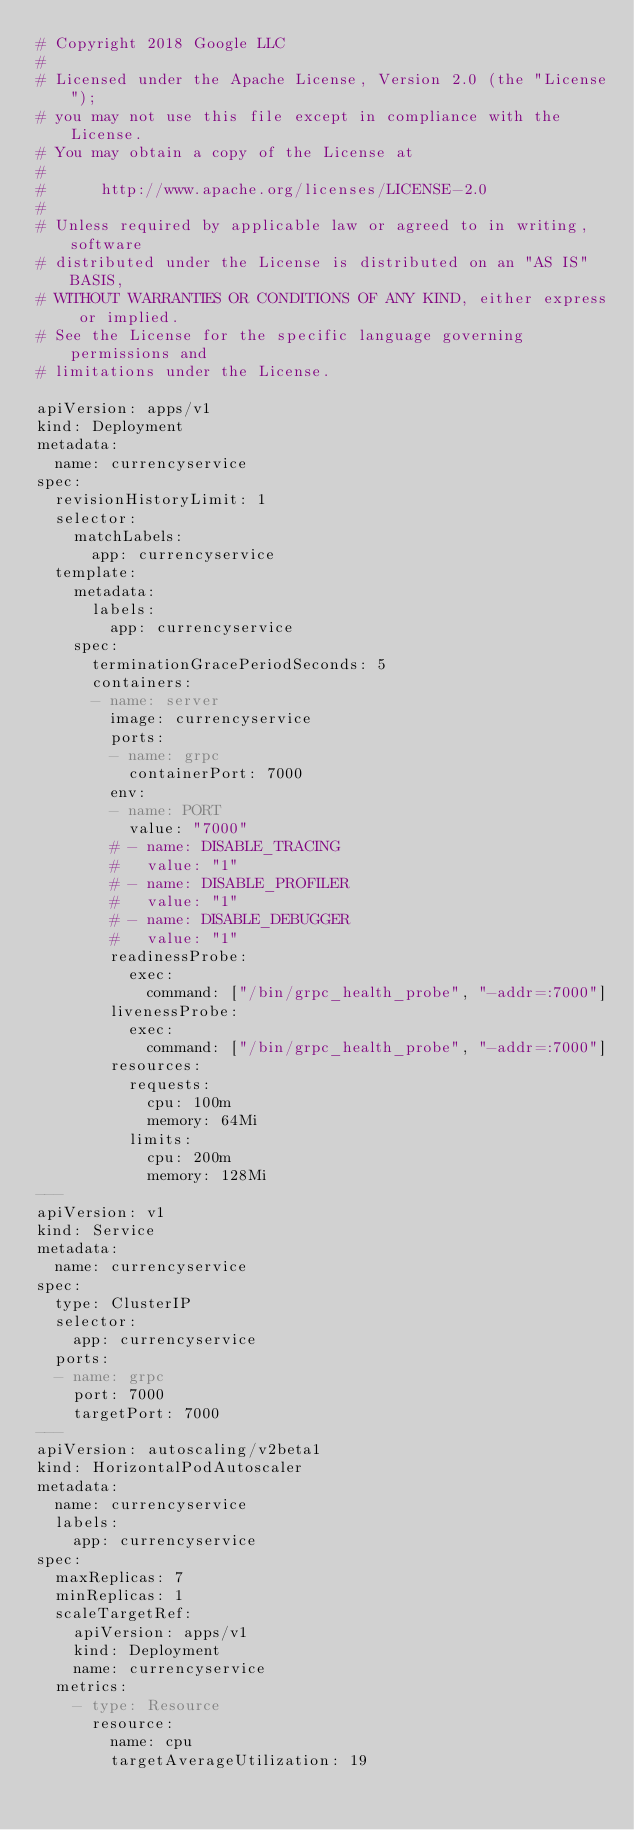<code> <loc_0><loc_0><loc_500><loc_500><_YAML_># Copyright 2018 Google LLC
#
# Licensed under the Apache License, Version 2.0 (the "License");
# you may not use this file except in compliance with the License.
# You may obtain a copy of the License at
#
#      http://www.apache.org/licenses/LICENSE-2.0
#
# Unless required by applicable law or agreed to in writing, software
# distributed under the License is distributed on an "AS IS" BASIS,
# WITHOUT WARRANTIES OR CONDITIONS OF ANY KIND, either express or implied.
# See the License for the specific language governing permissions and
# limitations under the License.

apiVersion: apps/v1
kind: Deployment
metadata:
  name: currencyservice
spec:
  revisionHistoryLimit: 1
  selector:
    matchLabels:
      app: currencyservice
  template:
    metadata:
      labels:
        app: currencyservice
    spec:
      terminationGracePeriodSeconds: 5
      containers:
      - name: server
        image: currencyservice
        ports:
        - name: grpc
          containerPort: 7000
        env:
        - name: PORT
          value: "7000"
        # - name: DISABLE_TRACING
        #   value: "1"
        # - name: DISABLE_PROFILER
        #   value: "1"
        # - name: DISABLE_DEBUGGER
        #   value: "1"
        readinessProbe:
          exec:
            command: ["/bin/grpc_health_probe", "-addr=:7000"]
        livenessProbe:
          exec:
            command: ["/bin/grpc_health_probe", "-addr=:7000"]
        resources:
          requests:
            cpu: 100m
            memory: 64Mi
          limits:
            cpu: 200m
            memory: 128Mi
---
apiVersion: v1
kind: Service
metadata:
  name: currencyservice
spec:
  type: ClusterIP
  selector:
    app: currencyservice
  ports:
  - name: grpc
    port: 7000
    targetPort: 7000
---
apiVersion: autoscaling/v2beta1
kind: HorizontalPodAutoscaler
metadata:
  name: currencyservice
  labels:
    app: currencyservice
spec:
  maxReplicas: 7
  minReplicas: 1
  scaleTargetRef:
    apiVersion: apps/v1
    kind: Deployment
    name: currencyservice
  metrics:
    - type: Resource
      resource:
        name: cpu
        targetAverageUtilization: 19
</code> 